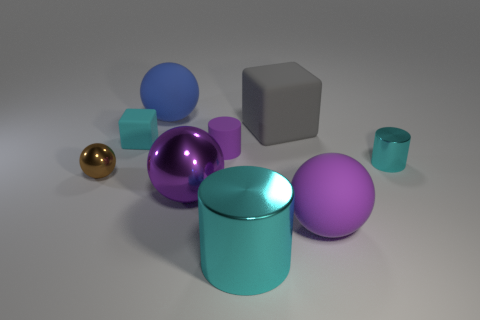Add 1 cyan cubes. How many objects exist? 10 Subtract all blocks. How many objects are left? 7 Subtract 0 yellow cubes. How many objects are left? 9 Subtract all small shiny balls. Subtract all big blue spheres. How many objects are left? 7 Add 3 cubes. How many cubes are left? 5 Add 3 brown balls. How many brown balls exist? 4 